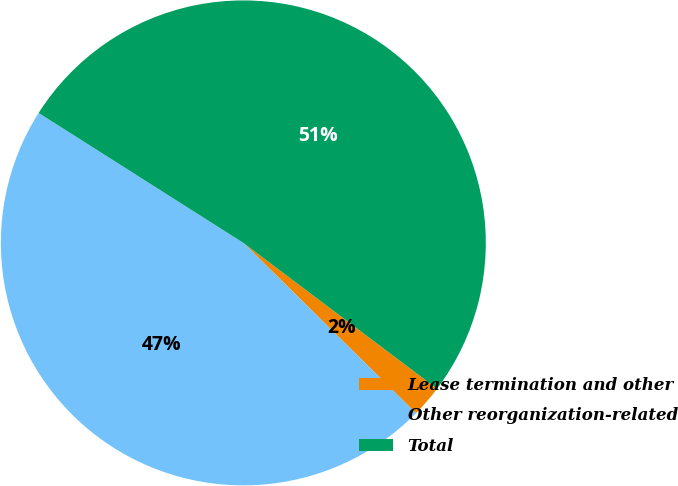<chart> <loc_0><loc_0><loc_500><loc_500><pie_chart><fcel>Lease termination and other<fcel>Other reorganization-related<fcel>Total<nl><fcel>2.12%<fcel>46.61%<fcel>51.27%<nl></chart> 